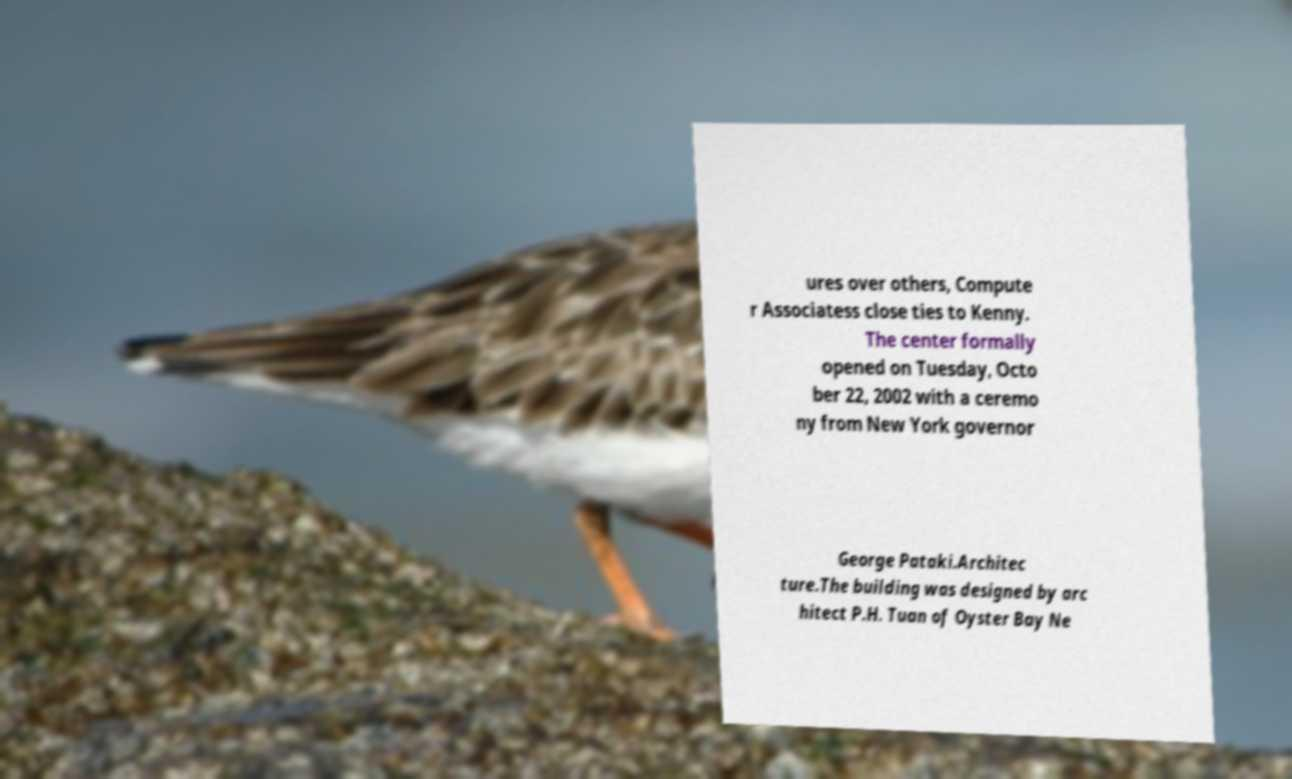I need the written content from this picture converted into text. Can you do that? ures over others, Compute r Associatess close ties to Kenny. The center formally opened on Tuesday, Octo ber 22, 2002 with a ceremo ny from New York governor George Pataki.Architec ture.The building was designed by arc hitect P.H. Tuan of Oyster Bay Ne 